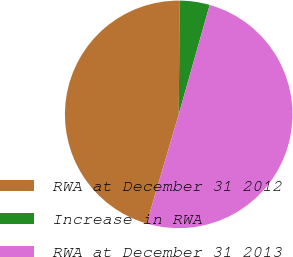Convert chart to OTSL. <chart><loc_0><loc_0><loc_500><loc_500><pie_chart><fcel>RWA at December 31 2012<fcel>Increase in RWA<fcel>RWA at December 31 2013<nl><fcel>45.6%<fcel>4.24%<fcel>50.16%<nl></chart> 